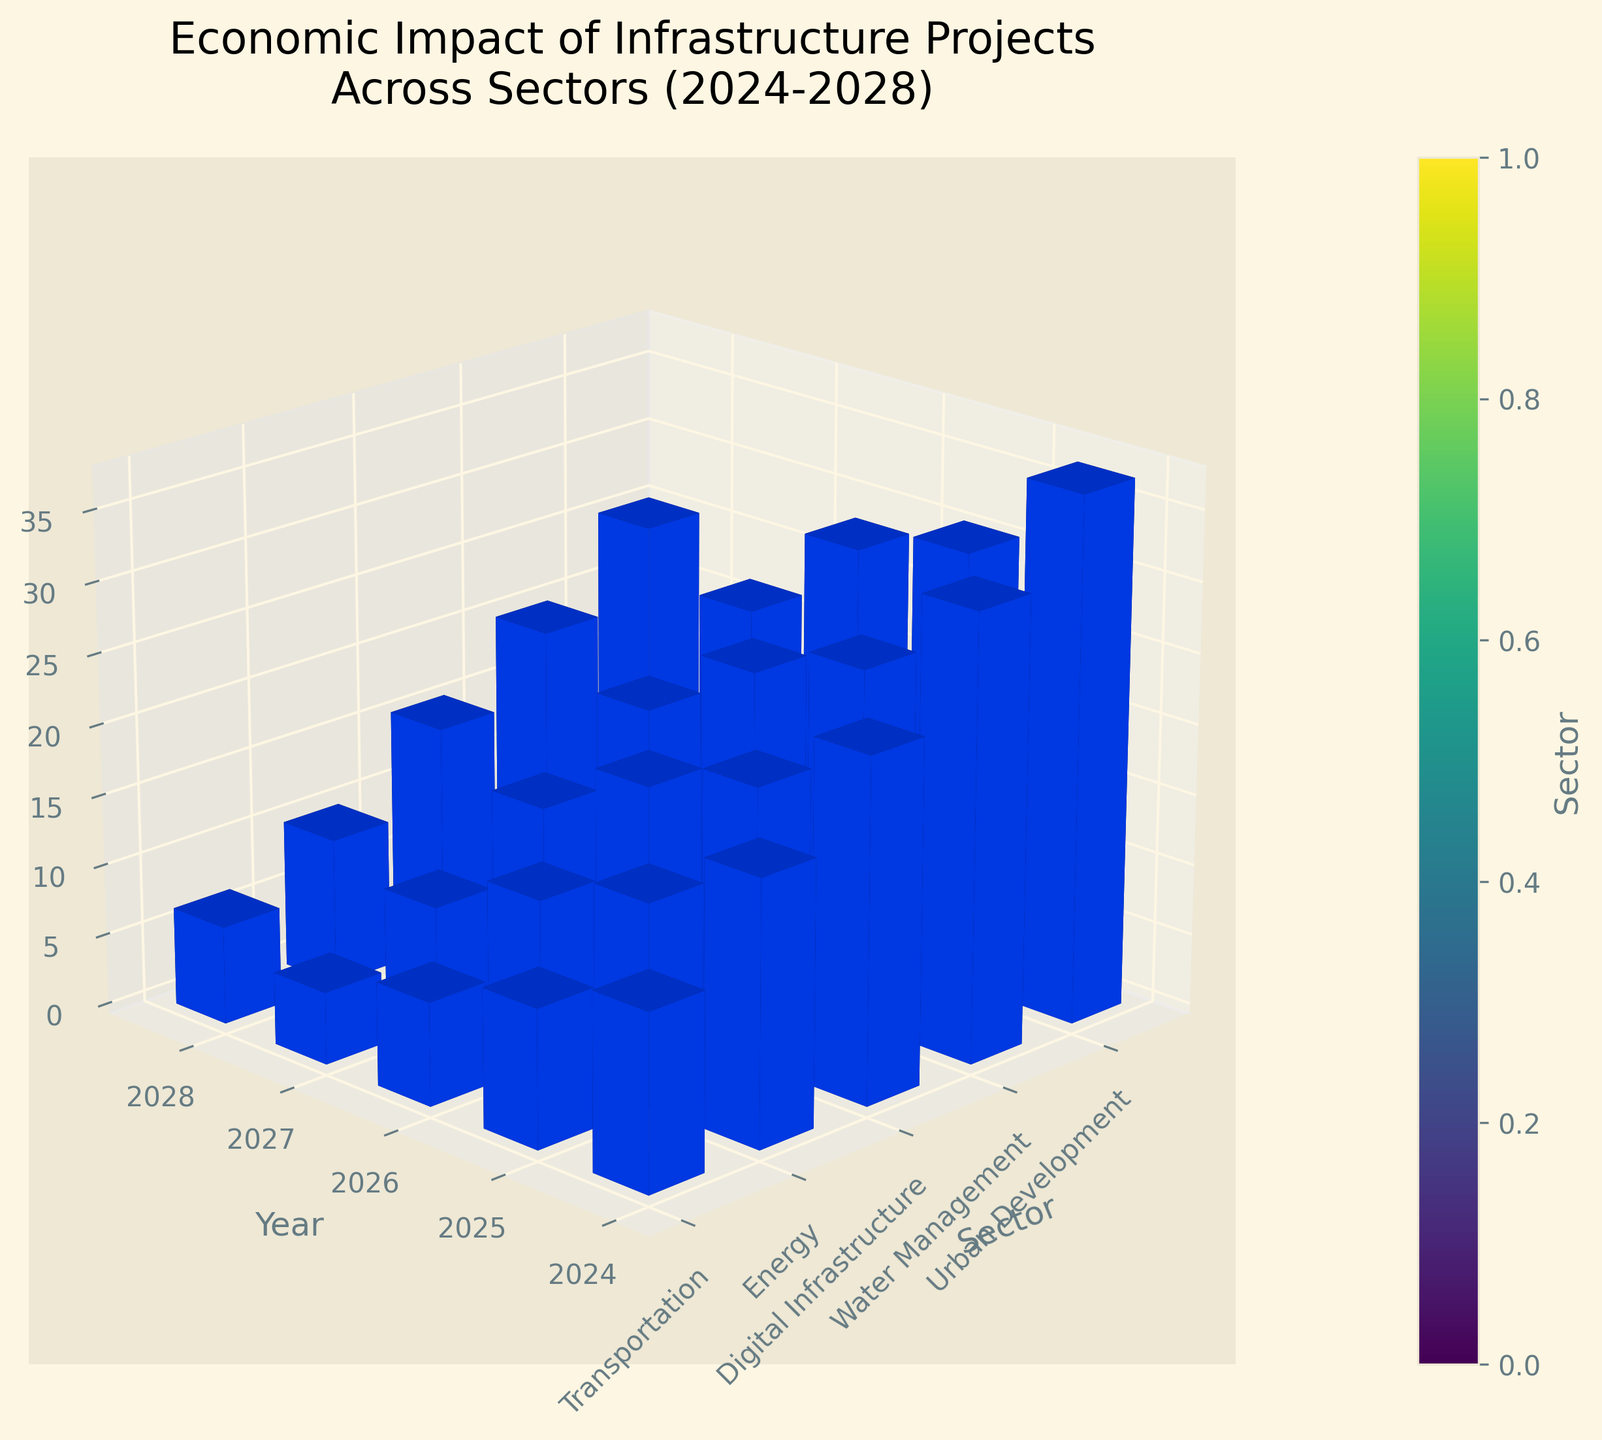Which sector has the highest economic impact in 2028? Look at the "Economic Impact (Billion USD)" values for 2028 across all sectors and identify the highest bar. The Transportation sector has the highest value at 37.2 billion USD.
Answer: Transportation What is the economic impact of Urban Development in 2025? Find the bar corresponding to Urban Development in the year 2025 and read the economic impact value off the z-axis. The value is 10.4 billion USD.
Answer: 10.4 billion USD Compare the economic impact of the Digital Infrastructure and Energy sectors in 2026. Which one is higher? Look at the heights of the bars for Digital Infrastructure and Energy in 2026. Digital Infrastructure's value is 16.9 billion USD, while Energy's value is 19.5 billion USD. Energy has a higher economic impact.
Answer: Energy What is the average economic impact of the Water Management sector over the years 2024 to 2028? Sum the economic impacts of Water Management from 2024 to 2028 and divide by the number of years. The values are 5.1, 8.3, 12.7, 17.2, and 21.9 billion USD. Calculate the sum: 5.1 + 8.3 + 12.7 + 17.2 + 21.9 = 65.2. Then divide by 5: 65.2 / 5 = 13.04.
Answer: 13.04 billion USD Is the economic impact of Transportation in 2028 greater than the combined impact of Energy and Digital Infrastructure in 2028? First, find the economic impact values: 
Transportation in 2028 is 37.2 billion USD, 
Energy in 2028 is 30.8 billion USD, 
Digital Infrastructure in 2028 is 28.7 billion USD. 
Now add Energy and Digital Infrastructure impacts: 30.8 + 28.7 = 59.5. 
Compare 37.2 with 59.5. No, it is not greater.
Answer: No By how much does the economic impact of the Digital Infrastructure sector increase from 2024 to 2028? Find the economic impact values for Digital Infrastructure in 2024 and 2028. The values are 7.3 billion USD and 28.7 billion USD, respectively. Subtract the earlier value from the later value: 28.7 - 7.3 = 21.4. The increase is 21.4 billion USD.
Answer: 21.4 billion USD Which sector shows the smallest economic impact in 2024, and what is that value? Identify the bars corresponding to different sectors in 2024 and find the smallest one. Water Management has the smallest economic impact at 5.1 billion USD.
Answer: Water Management, 5.1 billion USD What is the total economic impact across all sectors in 2026? Sum the economic impact values for all sectors in 2026. The values are:
- Transportation: 24.3
- Energy: 19.5
- Digital Infrastructure: 16.9
- Water Management: 12.7
- Urban Development: 15.8
Sum them up: 24.3 + 19.5 + 16.9 + 12.7 + 15.8 = 89.2 billion USD.
Answer: 89.2 billion USD Which year shows the highest total economic impact when considering all sectors combined? Sum the economic impact values for all sectors for each year. Find the year with the highest total.
2024: 12.5 + 9.8 + 7.3 + 5.1 + 6.9 = 41.6
2025: 18.7 + 14.2 + 11.6 + 8.3 + 10.4 = 63.2
2026: 24.3 + 19.5 + 16.9 + 12.7 + 15.8 = 89.2
2027: 31.6 + 25.1 + 22.4 + 17.2 + 20.3 = 116.6
2028: 37.2 + 30.8 + 28.7 + 21.9 + 25.6 = 144.2
2028 has the highest total.
Answer: 2028 